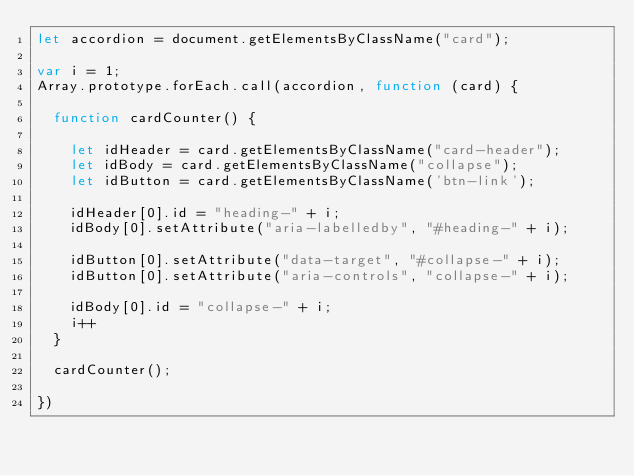<code> <loc_0><loc_0><loc_500><loc_500><_JavaScript_>let accordion = document.getElementsByClassName("card");

var i = 1;
Array.prototype.forEach.call(accordion, function (card) {

  function cardCounter() {

    let idHeader = card.getElementsByClassName("card-header");
    let idBody = card.getElementsByClassName("collapse");
    let idButton = card.getElementsByClassName('btn-link');

    idHeader[0].id = "heading-" + i;
    idBody[0].setAttribute("aria-labelledby", "#heading-" + i);

    idButton[0].setAttribute("data-target", "#collapse-" + i);
    idButton[0].setAttribute("aria-controls", "collapse-" + i);

    idBody[0].id = "collapse-" + i;
    i++
  }

  cardCounter();

})

</code> 